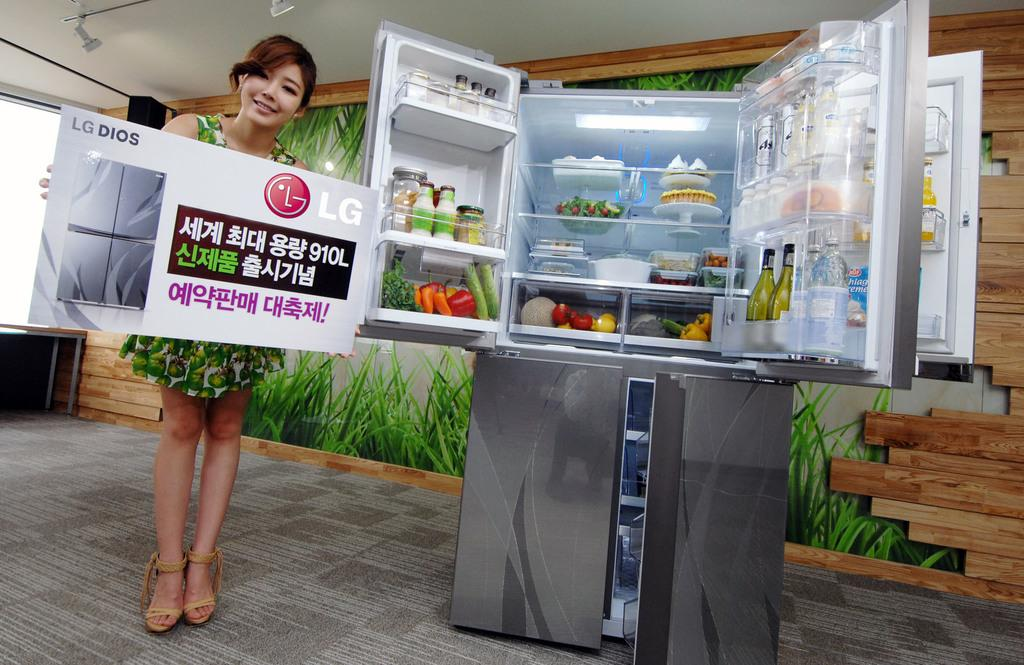Provide a one-sentence caption for the provided image. A woman holding a sign for LG Dios next to an open refrigerator. 